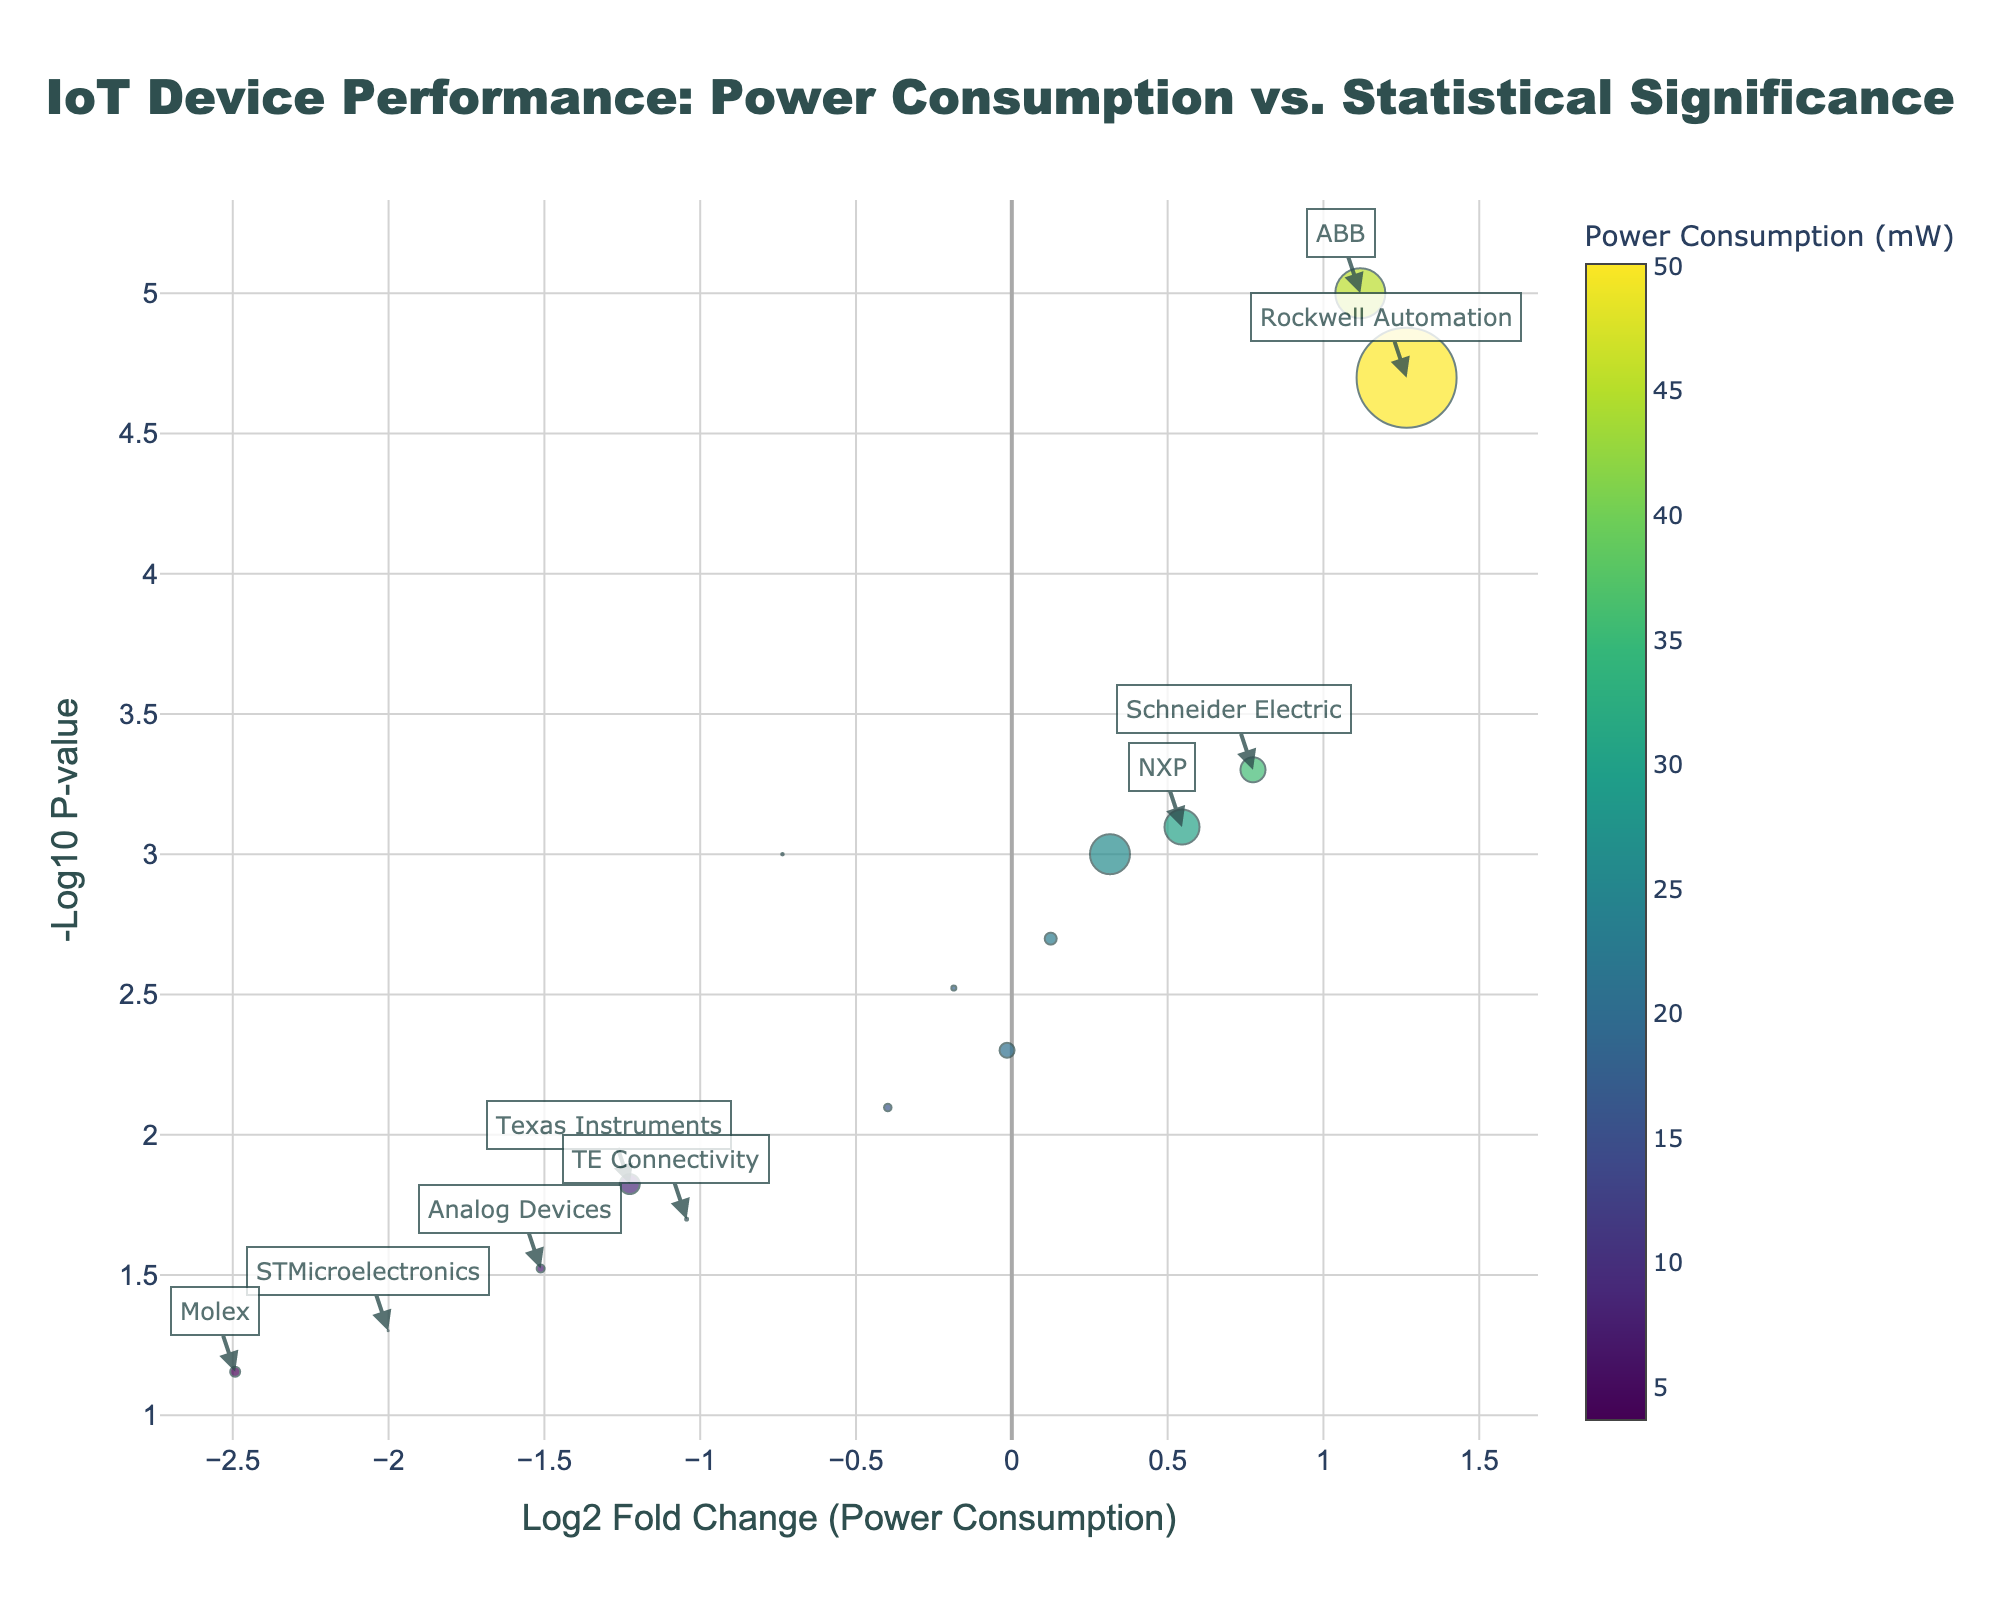What is the title of the plot? The title of the plot is displayed at the top. It reads "IoT Device Performance: Power Consumption vs. Statistical Significance".
Answer: IoT Device Performance: Power Consumption vs. Statistical Significance How is the marker size determined in the plot? The size of the markers is based on the data transmission rates (in Mbps). Larger markers correspond to higher data rates.
Answer: Data transmission rates Which device has the highest power consumption? Look for the marker with the highest value on the color scale (Viridis), which denotes power consumption. Hover over the marker, which is Rockwell Automation's PLC with 50.1 mW.
Answer: Rockwell Automation's PLC What are the axis labels? The x-axis label is "Log2 Fold Change (Power Consumption)", and the y-axis label is "-Log10 P-value". These labels are found directly beneath and beside the respective axes.
Answer: Log2 Fold Change (Power Consumption) and -Log10 P-value Which data point has the lowest p-value? The p-value is represented on the y-axis. The highest -log10(p-value) correspond to the lowest p-value. Rockwell Automation's PLC has the highest y-value, indicating the lowest p-value.
Answer: Rockwell Automation's PLC Which manufacturer has both a high data rate and low power consumption? Find markers with both a large size (high data rate) and color indicating lower power consumption on the Viridis scale. Texas Instruments' Wireless Module stands out with a data rate of 2.0 Mbps and power consumption of 8.9 mW.
Answer: Texas Instruments Which device type has a significant p-value (< 0.001) and a power consumption above average? Points with a p-value < 0.001 will be above the y-value corresponding to -log10(0.001). Identify points with a log2 fold change greater than 0 (indicating above-average power consumption). Examples include Schneider Electric's Smart Meter and ABB's Industrial Controller.
Answer: Schneider Electric's Smart Meter and ABB's Industrial Controller What can you say about the position of TE Connectivity's Humidity Sensor in terms of log2 fold change and -log10 p-value? TE Connectivity's Humidity Sensor sits to the left on the x-axis (negative log2 fold change, indicating lower power consumption) and is relatively lower on the y-axis (higher p-value). Its power consumption is below average, and its statistical significance is not as high.
Answer: Lower power consumption, higher p-value How does the power consumption of Analog Devices' Gyroscope compare to the average power consumption in this plot? To determine this, look at the log2 fold change. Analog Devices' Gyroscope is to the left of the center line (negative log2 fold change), indicating it has lower power consumption compared to the average.
Answer: Lower than average Which device has the smallest data rate and how is it visually represented in the plot? The smallest data rate is represented by the smallest marker size. STMicroelectronics' Accelerometer, which has a data rate of 0.1 Mbps and a small marker size, matches this criterion.
Answer: STMicroelectronics' Accelerometer 